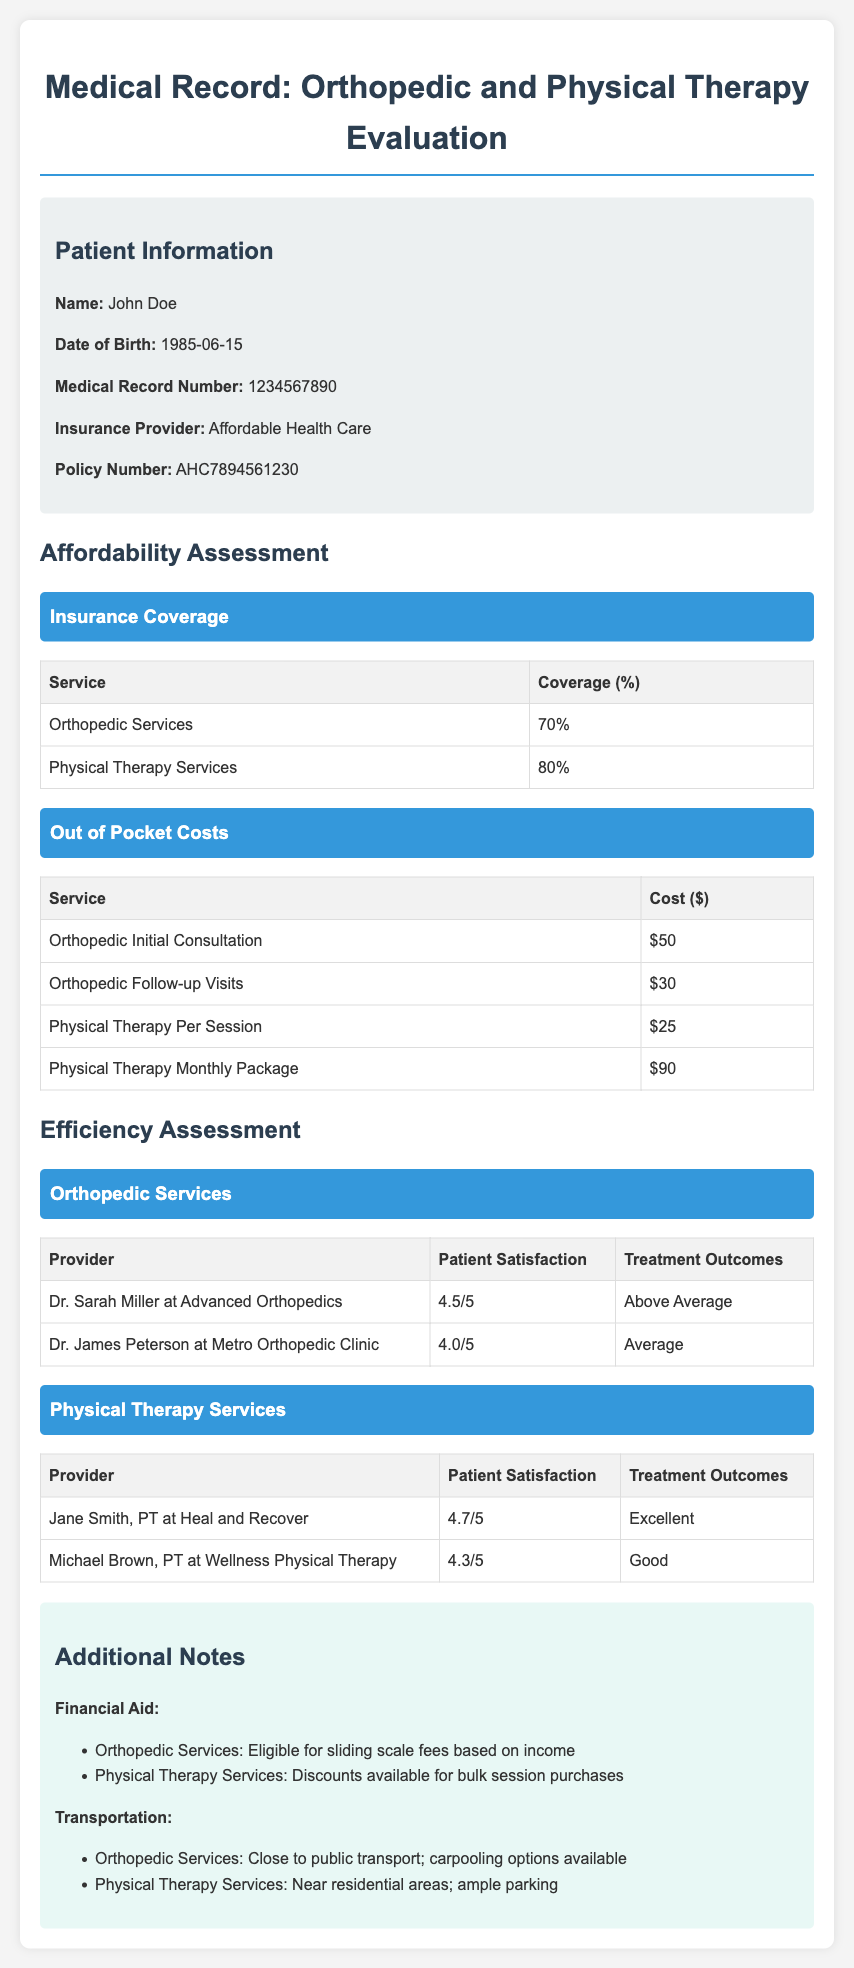What is the patient's name? The document provides the patient's name in the patient information section, which is John Doe.
Answer: John Doe What is the coverage percentage for Physical Therapy Services? The coverage percentage is listed in the affordability assessment table under Insurance Coverage.
Answer: 80% How much does an Orthopedic Follow-up Visit cost? The cost is shown in the out-of-pocket costs table for Orthopedic Services.
Answer: $30 Who is the Physical Therapy provider with the highest patient satisfaction? The document lists patient satisfaction ratings for various providers in the efficiency assessment. Jane Smith, PT at Heal and Recover has the highest rating of 4.7/5.
Answer: Jane Smith, PT at Heal and Recover What is the financial aid option for Physical Therapy Services? The document mentions available financial aid options and discounts in the additional notes section.
Answer: Discounts available for bulk session purchases What is the cost of Physical Therapy Monthly Package? The cost is presented in the out-of-pocket costs table.
Answer: $90 Which orthopedic provider has above-average treatment outcomes? The document indicates treatment outcomes in the efficiency assessment section; Dr. Sarah Miller at Advanced Orthopedics has above-average outcomes.
Answer: Dr. Sarah Miller at Advanced Orthopedics What are the transportation options for Orthopedic Services? The transportation information is provided in the additional notes, detailing accessibility options.
Answer: Close to public transport; carpooling options available 